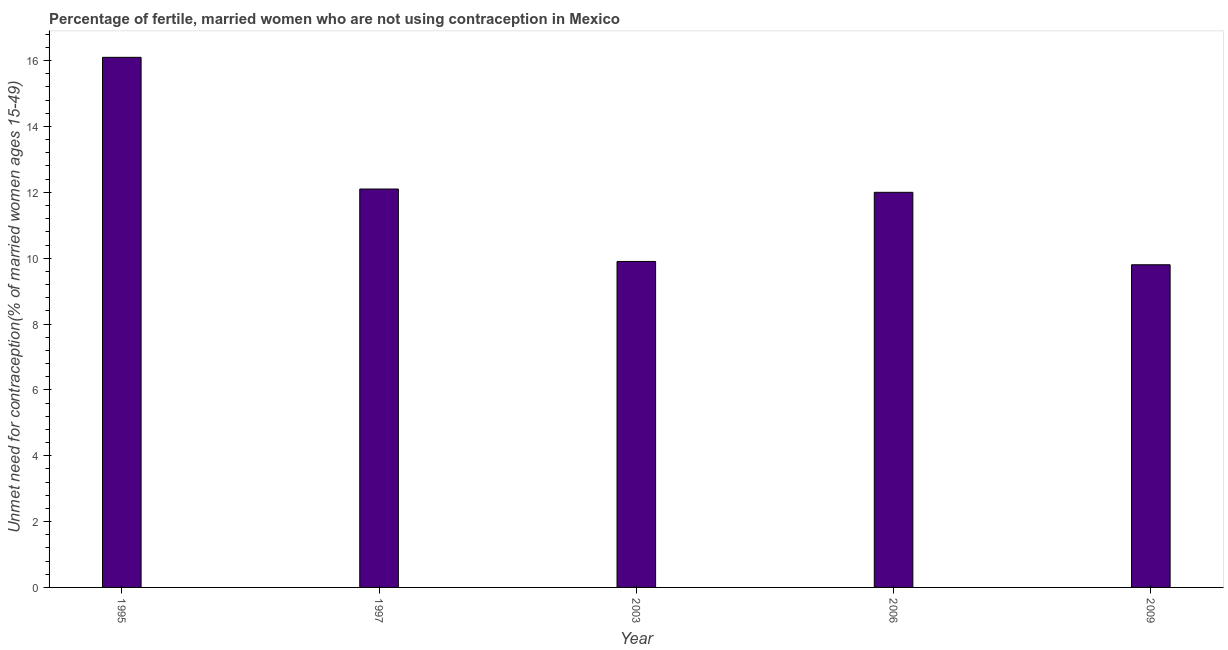What is the title of the graph?
Provide a short and direct response. Percentage of fertile, married women who are not using contraception in Mexico. What is the label or title of the Y-axis?
Ensure brevity in your answer.   Unmet need for contraception(% of married women ages 15-49). What is the number of married women who are not using contraception in 2009?
Give a very brief answer. 9.8. Across all years, what is the minimum number of married women who are not using contraception?
Ensure brevity in your answer.  9.8. What is the sum of the number of married women who are not using contraception?
Keep it short and to the point. 59.9. What is the difference between the number of married women who are not using contraception in 1997 and 2003?
Offer a very short reply. 2.2. What is the average number of married women who are not using contraception per year?
Give a very brief answer. 11.98. Do a majority of the years between 2006 and 1997 (inclusive) have number of married women who are not using contraception greater than 11.6 %?
Offer a very short reply. Yes. Is the number of married women who are not using contraception in 2006 less than that in 2009?
Provide a short and direct response. No. Is the difference between the number of married women who are not using contraception in 1997 and 2006 greater than the difference between any two years?
Your answer should be very brief. No. What is the difference between the highest and the lowest number of married women who are not using contraception?
Give a very brief answer. 6.3. How many years are there in the graph?
Make the answer very short. 5. What is the  Unmet need for contraception(% of married women ages 15-49) of 2006?
Provide a short and direct response. 12. What is the  Unmet need for contraception(% of married women ages 15-49) of 2009?
Make the answer very short. 9.8. What is the difference between the  Unmet need for contraception(% of married women ages 15-49) in 1995 and 1997?
Make the answer very short. 4. What is the difference between the  Unmet need for contraception(% of married women ages 15-49) in 1995 and 2003?
Ensure brevity in your answer.  6.2. What is the difference between the  Unmet need for contraception(% of married women ages 15-49) in 1995 and 2009?
Make the answer very short. 6.3. What is the difference between the  Unmet need for contraception(% of married women ages 15-49) in 1997 and 2003?
Offer a very short reply. 2.2. What is the difference between the  Unmet need for contraception(% of married women ages 15-49) in 2003 and 2009?
Your answer should be very brief. 0.1. What is the difference between the  Unmet need for contraception(% of married women ages 15-49) in 2006 and 2009?
Provide a succinct answer. 2.2. What is the ratio of the  Unmet need for contraception(% of married women ages 15-49) in 1995 to that in 1997?
Your answer should be very brief. 1.33. What is the ratio of the  Unmet need for contraception(% of married women ages 15-49) in 1995 to that in 2003?
Offer a terse response. 1.63. What is the ratio of the  Unmet need for contraception(% of married women ages 15-49) in 1995 to that in 2006?
Ensure brevity in your answer.  1.34. What is the ratio of the  Unmet need for contraception(% of married women ages 15-49) in 1995 to that in 2009?
Make the answer very short. 1.64. What is the ratio of the  Unmet need for contraception(% of married women ages 15-49) in 1997 to that in 2003?
Give a very brief answer. 1.22. What is the ratio of the  Unmet need for contraception(% of married women ages 15-49) in 1997 to that in 2009?
Offer a terse response. 1.24. What is the ratio of the  Unmet need for contraception(% of married women ages 15-49) in 2003 to that in 2006?
Provide a short and direct response. 0.82. What is the ratio of the  Unmet need for contraception(% of married women ages 15-49) in 2003 to that in 2009?
Make the answer very short. 1.01. What is the ratio of the  Unmet need for contraception(% of married women ages 15-49) in 2006 to that in 2009?
Your response must be concise. 1.22. 